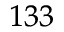Convert formula to latex. <formula><loc_0><loc_0><loc_500><loc_500>^ { 1 3 3 }</formula> 